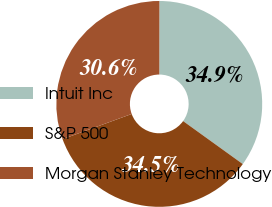Convert chart to OTSL. <chart><loc_0><loc_0><loc_500><loc_500><pie_chart><fcel>Intuit Inc<fcel>S&P 500<fcel>Morgan Stanley Technology<nl><fcel>34.92%<fcel>34.5%<fcel>30.58%<nl></chart> 